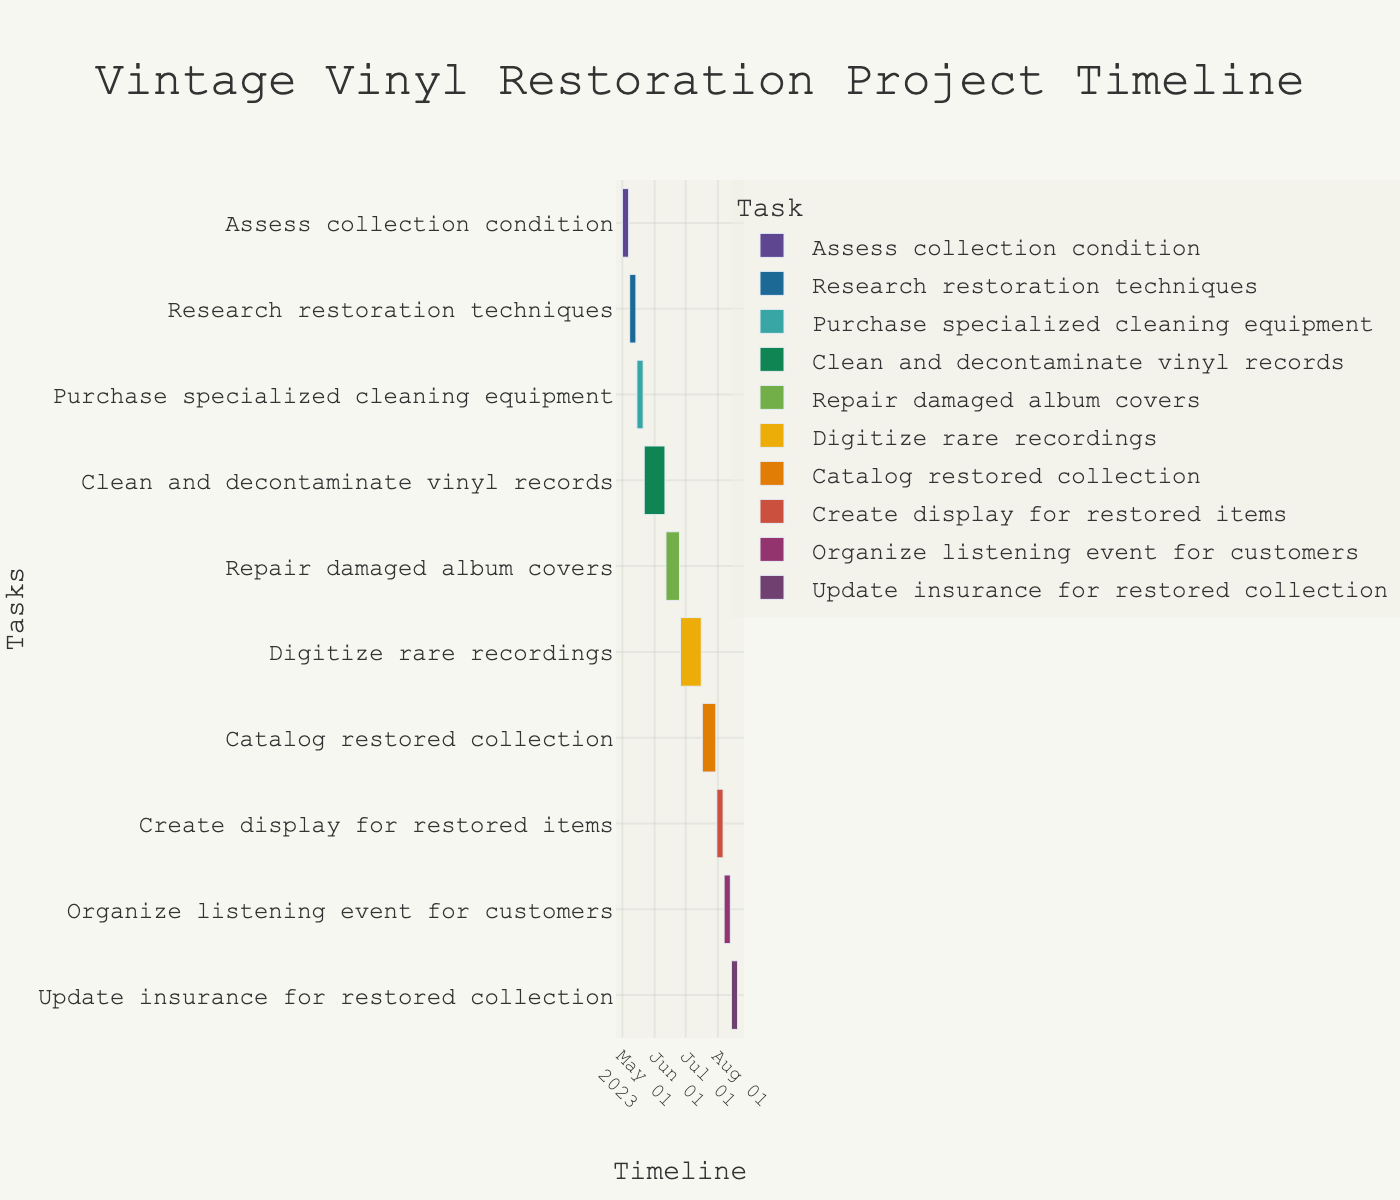What's the title of the Gantt chart? The title is displayed at the top of the Gantt chart. Identify it by reading the bold, large text centered at the top.
Answer: Vintage Vinyl Restoration Project Timeline What task starts on May 15, 2023? Look for the start date of May 15, 2023, on the Gantt chart and check the corresponding task name on the left axis.
Answer: Purchase specialized cleaning equipment What is the duration of the task 'Clean and decontaminate vinyl records'? Observe the length of the bar corresponding to 'Clean and decontaminate vinyl records' and count the number of days between its start and end dates. The task starts on May 22, 2023, and ends on June 11, 2023. The duration is 20 days.
Answer: 20 days Which task takes the longest to complete? Compare the lengths of all the tasks' bars on the chart. The longest bar corresponds to the task 'Clean and decontaminate vinyl records'.
Answer: Clean and decontaminate vinyl records How many tasks are scheduled for July 2023? Identify the tasks that are scheduled to start, end, or occur within July 2023 by looking at the timeline and the respective dates. 'Digitize rare recordings', 'Catalog restored collection', and 'Create display for restored items' are in July.
Answer: 3 tasks Which task ends on August 6, 2023? Find the end date of August 6, 2023, on the timeline and the corresponding task on the y-axis. This is the 'Create display for restored items' task.
Answer: Create display for restored items Do any tasks overlap with 'Repair damaged album covers'? If so, which ones? Check the timeline for other bars that overlap with 'Repair damaged album covers' from June 12, 2023, to June 25, 2023. 'Clean and decontaminate vinyl records' overlaps on June 12, 2023.
Answer: Clean and decontaminate vinyl records Which task is scheduled right before 'Organize listening event for customers'? Identify the task that ends just before the start date of 'Organize listening event for customers' which starts on August 7, 2023. This preceding task is 'Create display for restored items' ending on August 6, 2023.
Answer: Create display for restored items From the start of 'Assess collection condition' to the end of 'Organize listening event for customers', how many days does the project take? Calculate the total duration by counting the days from the start date of 'Assess collection condition' (May 1, 2023) to the end date of 'Organize listening event for customers' (August 13, 2023). The total duration is 105 days.
Answer: 105 days 